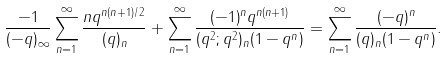Convert formula to latex. <formula><loc_0><loc_0><loc_500><loc_500>\frac { - 1 } { ( - q ) _ { \infty } } \sum _ { n = 1 } ^ { \infty } \frac { n q ^ { n ( n + 1 ) / 2 } } { ( q ) _ { n } } + \sum _ { n = 1 } ^ { \infty } \frac { ( - 1 ) ^ { n } q ^ { n ( n + 1 ) } } { ( q ^ { 2 } ; q ^ { 2 } ) _ { n } ( 1 - q ^ { n } ) } = \sum _ { n = 1 } ^ { \infty } \frac { ( - q ) ^ { n } } { ( q ) _ { n } ( 1 - q ^ { n } ) } .</formula> 